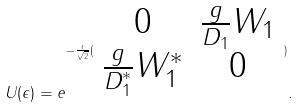<formula> <loc_0><loc_0><loc_500><loc_500>U ( \epsilon ) = e ^ { - \frac { i } { \sqrt { 2 } } ( \begin{array} { c c } 0 & \frac { g } { D _ { 1 } } W _ { 1 } \\ \frac { g } { D _ { 1 } ^ { * } } W _ { 1 } ^ { * } & 0 \end{array} ) } .</formula> 